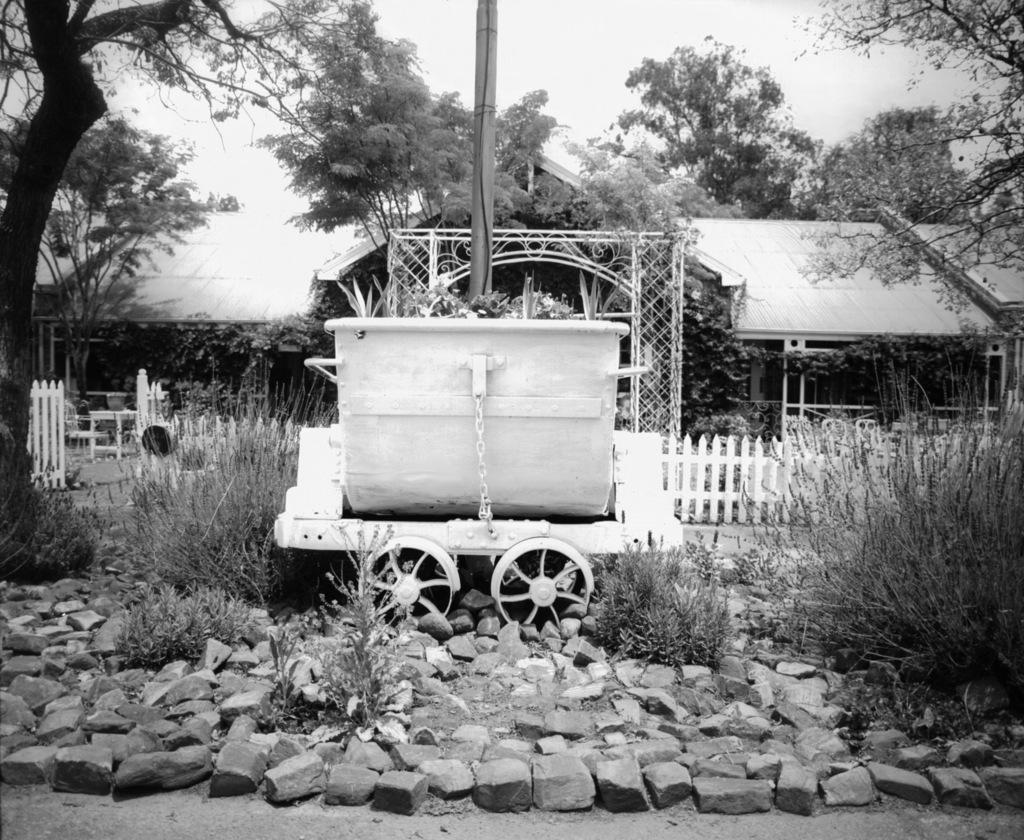How would you summarize this image in a sentence or two? There are stones, it seems like a boat on the wheels and plants in the foreground area of the image, there are houses, boundary, trees and the sky in the background. 